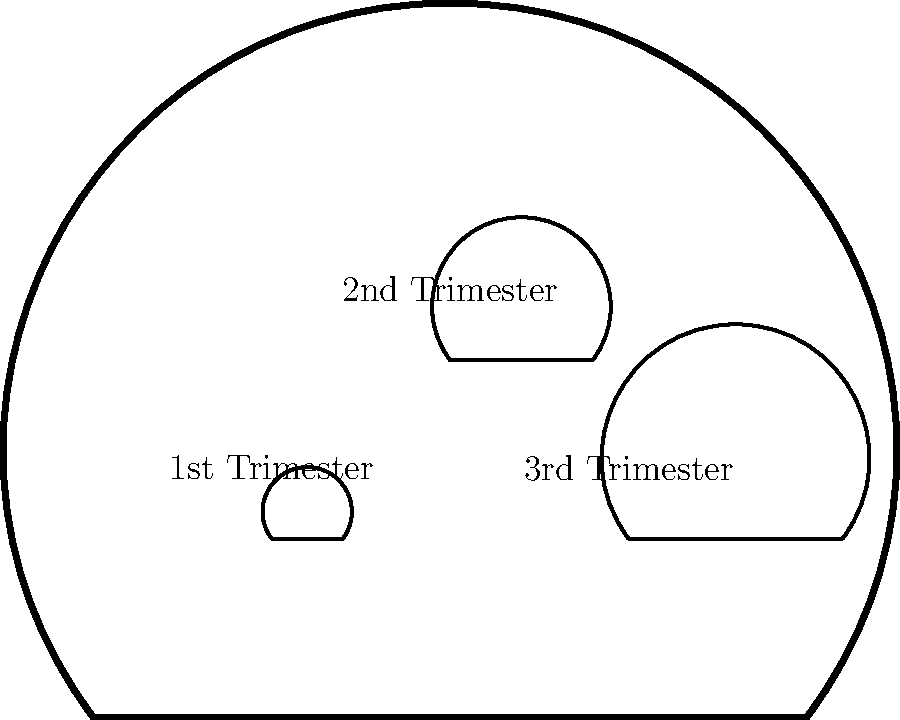In the diagram illustrating fetal development stages, which trimester is associated with the largest fetus representation? To answer this question, we need to analyze the diagram of fetal development in the uterus:

1. The diagram shows three fetus outlines of different sizes within the uterus.
2. Each outline is labeled with a trimester:
   - The smallest outline is labeled "1st Trimester"
   - The medium-sized outline is labeled "2nd Trimester"
   - The largest outline is labeled "3rd Trimester"
3. The size of each fetus representation corresponds to the growth and development during each trimester.
4. The 3rd trimester fetus is clearly the largest, representing the most advanced stage of fetal development.

Therefore, the largest fetus representation in the diagram is associated with the 3rd trimester.
Answer: 3rd Trimester 